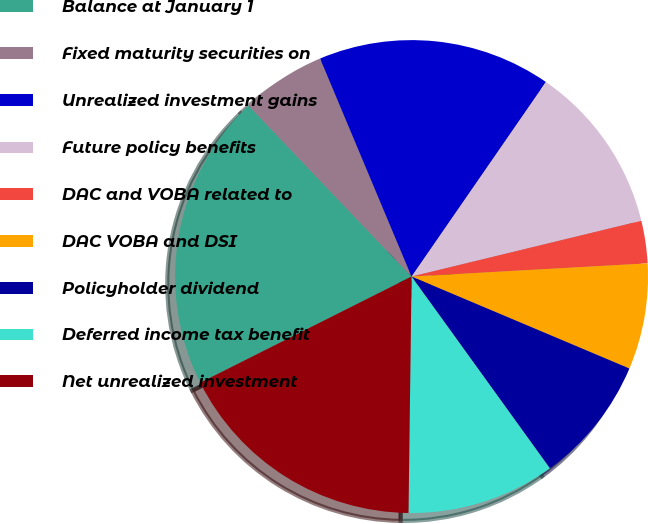<chart> <loc_0><loc_0><loc_500><loc_500><pie_chart><fcel>Balance at January 1<fcel>Fixed maturity securities on<fcel>Unrealized investment gains<fcel>Future policy benefits<fcel>DAC and VOBA related to<fcel>DAC VOBA and DSI<fcel>Policyholder dividend<fcel>Deferred income tax benefit<fcel>Net unrealized investment<nl><fcel>20.29%<fcel>5.8%<fcel>15.94%<fcel>11.59%<fcel>2.9%<fcel>7.25%<fcel>8.7%<fcel>10.15%<fcel>17.39%<nl></chart> 